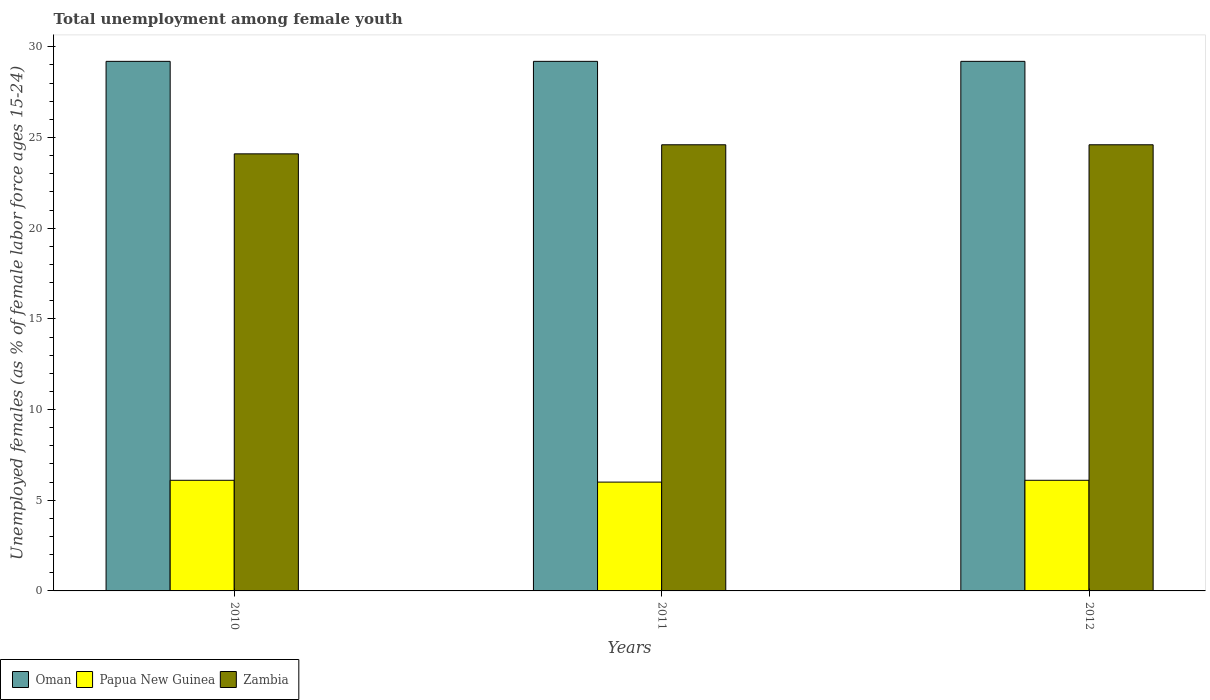How many different coloured bars are there?
Provide a short and direct response. 3. Are the number of bars per tick equal to the number of legend labels?
Your answer should be compact. Yes. Are the number of bars on each tick of the X-axis equal?
Your answer should be compact. Yes. How many bars are there on the 3rd tick from the left?
Your response must be concise. 3. What is the label of the 2nd group of bars from the left?
Provide a succinct answer. 2011. What is the percentage of unemployed females in in Oman in 2010?
Offer a terse response. 29.2. Across all years, what is the maximum percentage of unemployed females in in Oman?
Keep it short and to the point. 29.2. Across all years, what is the minimum percentage of unemployed females in in Zambia?
Make the answer very short. 24.1. In which year was the percentage of unemployed females in in Papua New Guinea minimum?
Offer a very short reply. 2011. What is the total percentage of unemployed females in in Oman in the graph?
Provide a succinct answer. 87.6. What is the difference between the percentage of unemployed females in in Papua New Guinea in 2011 and that in 2012?
Offer a terse response. -0.1. What is the difference between the percentage of unemployed females in in Zambia in 2011 and the percentage of unemployed females in in Oman in 2012?
Offer a terse response. -4.6. What is the average percentage of unemployed females in in Oman per year?
Make the answer very short. 29.2. In the year 2010, what is the difference between the percentage of unemployed females in in Oman and percentage of unemployed females in in Zambia?
Your answer should be compact. 5.1. In how many years, is the percentage of unemployed females in in Oman greater than 23 %?
Your response must be concise. 3. What is the ratio of the percentage of unemployed females in in Papua New Guinea in 2010 to that in 2011?
Provide a short and direct response. 1.02. Is the difference between the percentage of unemployed females in in Oman in 2010 and 2011 greater than the difference between the percentage of unemployed females in in Zambia in 2010 and 2011?
Your answer should be compact. Yes. What is the difference between the highest and the second highest percentage of unemployed females in in Zambia?
Offer a terse response. 0. What does the 2nd bar from the left in 2012 represents?
Give a very brief answer. Papua New Guinea. What does the 2nd bar from the right in 2012 represents?
Offer a very short reply. Papua New Guinea. Is it the case that in every year, the sum of the percentage of unemployed females in in Zambia and percentage of unemployed females in in Oman is greater than the percentage of unemployed females in in Papua New Guinea?
Your answer should be very brief. Yes. How many bars are there?
Your answer should be very brief. 9. Are all the bars in the graph horizontal?
Keep it short and to the point. No. How many years are there in the graph?
Give a very brief answer. 3. Are the values on the major ticks of Y-axis written in scientific E-notation?
Keep it short and to the point. No. Does the graph contain grids?
Your answer should be compact. No. How many legend labels are there?
Provide a short and direct response. 3. What is the title of the graph?
Make the answer very short. Total unemployment among female youth. What is the label or title of the Y-axis?
Keep it short and to the point. Unemployed females (as % of female labor force ages 15-24). What is the Unemployed females (as % of female labor force ages 15-24) of Oman in 2010?
Ensure brevity in your answer.  29.2. What is the Unemployed females (as % of female labor force ages 15-24) of Papua New Guinea in 2010?
Provide a succinct answer. 6.1. What is the Unemployed females (as % of female labor force ages 15-24) in Zambia in 2010?
Provide a short and direct response. 24.1. What is the Unemployed females (as % of female labor force ages 15-24) of Oman in 2011?
Your answer should be very brief. 29.2. What is the Unemployed females (as % of female labor force ages 15-24) in Zambia in 2011?
Make the answer very short. 24.6. What is the Unemployed females (as % of female labor force ages 15-24) in Oman in 2012?
Give a very brief answer. 29.2. What is the Unemployed females (as % of female labor force ages 15-24) in Papua New Guinea in 2012?
Make the answer very short. 6.1. What is the Unemployed females (as % of female labor force ages 15-24) in Zambia in 2012?
Offer a terse response. 24.6. Across all years, what is the maximum Unemployed females (as % of female labor force ages 15-24) in Oman?
Give a very brief answer. 29.2. Across all years, what is the maximum Unemployed females (as % of female labor force ages 15-24) in Papua New Guinea?
Your response must be concise. 6.1. Across all years, what is the maximum Unemployed females (as % of female labor force ages 15-24) in Zambia?
Provide a succinct answer. 24.6. Across all years, what is the minimum Unemployed females (as % of female labor force ages 15-24) of Oman?
Your answer should be very brief. 29.2. Across all years, what is the minimum Unemployed females (as % of female labor force ages 15-24) of Zambia?
Provide a succinct answer. 24.1. What is the total Unemployed females (as % of female labor force ages 15-24) in Oman in the graph?
Make the answer very short. 87.6. What is the total Unemployed females (as % of female labor force ages 15-24) in Papua New Guinea in the graph?
Keep it short and to the point. 18.2. What is the total Unemployed females (as % of female labor force ages 15-24) in Zambia in the graph?
Give a very brief answer. 73.3. What is the difference between the Unemployed females (as % of female labor force ages 15-24) of Oman in 2010 and that in 2011?
Ensure brevity in your answer.  0. What is the difference between the Unemployed females (as % of female labor force ages 15-24) of Zambia in 2010 and that in 2011?
Your response must be concise. -0.5. What is the difference between the Unemployed females (as % of female labor force ages 15-24) in Papua New Guinea in 2010 and that in 2012?
Offer a terse response. 0. What is the difference between the Unemployed females (as % of female labor force ages 15-24) in Zambia in 2010 and that in 2012?
Keep it short and to the point. -0.5. What is the difference between the Unemployed females (as % of female labor force ages 15-24) in Oman in 2011 and that in 2012?
Make the answer very short. 0. What is the difference between the Unemployed females (as % of female labor force ages 15-24) in Papua New Guinea in 2011 and that in 2012?
Your answer should be very brief. -0.1. What is the difference between the Unemployed females (as % of female labor force ages 15-24) of Oman in 2010 and the Unemployed females (as % of female labor force ages 15-24) of Papua New Guinea in 2011?
Your answer should be very brief. 23.2. What is the difference between the Unemployed females (as % of female labor force ages 15-24) of Papua New Guinea in 2010 and the Unemployed females (as % of female labor force ages 15-24) of Zambia in 2011?
Your answer should be compact. -18.5. What is the difference between the Unemployed females (as % of female labor force ages 15-24) in Oman in 2010 and the Unemployed females (as % of female labor force ages 15-24) in Papua New Guinea in 2012?
Your answer should be very brief. 23.1. What is the difference between the Unemployed females (as % of female labor force ages 15-24) of Papua New Guinea in 2010 and the Unemployed females (as % of female labor force ages 15-24) of Zambia in 2012?
Make the answer very short. -18.5. What is the difference between the Unemployed females (as % of female labor force ages 15-24) in Oman in 2011 and the Unemployed females (as % of female labor force ages 15-24) in Papua New Guinea in 2012?
Offer a terse response. 23.1. What is the difference between the Unemployed females (as % of female labor force ages 15-24) in Oman in 2011 and the Unemployed females (as % of female labor force ages 15-24) in Zambia in 2012?
Make the answer very short. 4.6. What is the difference between the Unemployed females (as % of female labor force ages 15-24) of Papua New Guinea in 2011 and the Unemployed females (as % of female labor force ages 15-24) of Zambia in 2012?
Offer a terse response. -18.6. What is the average Unemployed females (as % of female labor force ages 15-24) of Oman per year?
Provide a succinct answer. 29.2. What is the average Unemployed females (as % of female labor force ages 15-24) in Papua New Guinea per year?
Keep it short and to the point. 6.07. What is the average Unemployed females (as % of female labor force ages 15-24) in Zambia per year?
Your answer should be compact. 24.43. In the year 2010, what is the difference between the Unemployed females (as % of female labor force ages 15-24) of Oman and Unemployed females (as % of female labor force ages 15-24) of Papua New Guinea?
Your answer should be very brief. 23.1. In the year 2010, what is the difference between the Unemployed females (as % of female labor force ages 15-24) of Oman and Unemployed females (as % of female labor force ages 15-24) of Zambia?
Your answer should be compact. 5.1. In the year 2010, what is the difference between the Unemployed females (as % of female labor force ages 15-24) in Papua New Guinea and Unemployed females (as % of female labor force ages 15-24) in Zambia?
Your response must be concise. -18. In the year 2011, what is the difference between the Unemployed females (as % of female labor force ages 15-24) in Oman and Unemployed females (as % of female labor force ages 15-24) in Papua New Guinea?
Keep it short and to the point. 23.2. In the year 2011, what is the difference between the Unemployed females (as % of female labor force ages 15-24) in Papua New Guinea and Unemployed females (as % of female labor force ages 15-24) in Zambia?
Offer a terse response. -18.6. In the year 2012, what is the difference between the Unemployed females (as % of female labor force ages 15-24) in Oman and Unemployed females (as % of female labor force ages 15-24) in Papua New Guinea?
Keep it short and to the point. 23.1. In the year 2012, what is the difference between the Unemployed females (as % of female labor force ages 15-24) of Oman and Unemployed females (as % of female labor force ages 15-24) of Zambia?
Your response must be concise. 4.6. In the year 2012, what is the difference between the Unemployed females (as % of female labor force ages 15-24) of Papua New Guinea and Unemployed females (as % of female labor force ages 15-24) of Zambia?
Give a very brief answer. -18.5. What is the ratio of the Unemployed females (as % of female labor force ages 15-24) of Oman in 2010 to that in 2011?
Ensure brevity in your answer.  1. What is the ratio of the Unemployed females (as % of female labor force ages 15-24) of Papua New Guinea in 2010 to that in 2011?
Offer a very short reply. 1.02. What is the ratio of the Unemployed females (as % of female labor force ages 15-24) of Zambia in 2010 to that in 2011?
Your answer should be compact. 0.98. What is the ratio of the Unemployed females (as % of female labor force ages 15-24) in Oman in 2010 to that in 2012?
Offer a terse response. 1. What is the ratio of the Unemployed females (as % of female labor force ages 15-24) of Zambia in 2010 to that in 2012?
Keep it short and to the point. 0.98. What is the ratio of the Unemployed females (as % of female labor force ages 15-24) in Oman in 2011 to that in 2012?
Provide a short and direct response. 1. What is the ratio of the Unemployed females (as % of female labor force ages 15-24) of Papua New Guinea in 2011 to that in 2012?
Your answer should be compact. 0.98. What is the difference between the highest and the second highest Unemployed females (as % of female labor force ages 15-24) of Zambia?
Your answer should be very brief. 0. What is the difference between the highest and the lowest Unemployed females (as % of female labor force ages 15-24) in Oman?
Offer a very short reply. 0. What is the difference between the highest and the lowest Unemployed females (as % of female labor force ages 15-24) in Papua New Guinea?
Offer a very short reply. 0.1. 